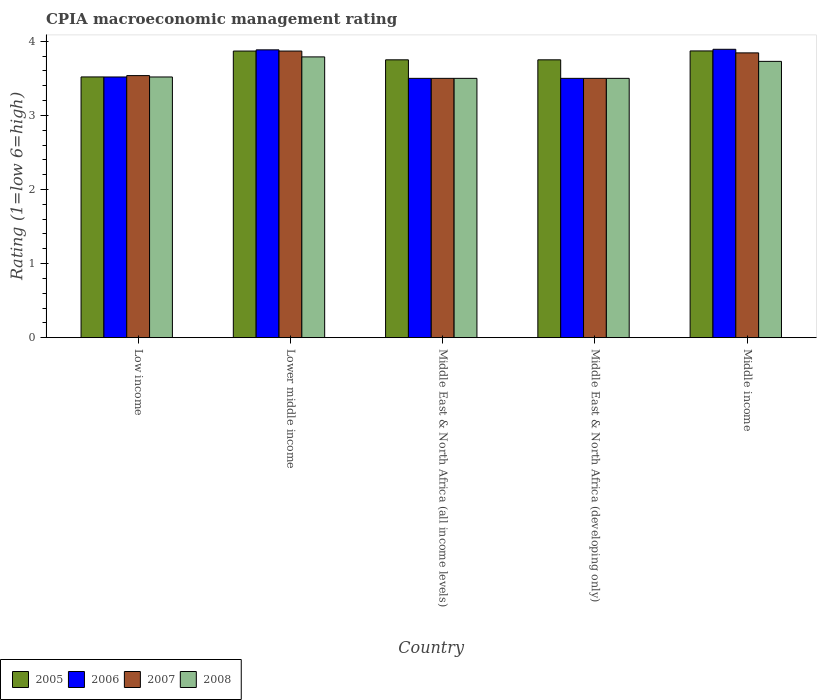How many different coloured bars are there?
Offer a very short reply. 4. How many groups of bars are there?
Your answer should be very brief. 5. Are the number of bars per tick equal to the number of legend labels?
Offer a very short reply. Yes. How many bars are there on the 3rd tick from the right?
Make the answer very short. 4. What is the label of the 4th group of bars from the left?
Offer a very short reply. Middle East & North Africa (developing only). In how many cases, is the number of bars for a given country not equal to the number of legend labels?
Ensure brevity in your answer.  0. What is the CPIA rating in 2006 in Low income?
Provide a succinct answer. 3.52. Across all countries, what is the maximum CPIA rating in 2005?
Make the answer very short. 3.87. Across all countries, what is the minimum CPIA rating in 2006?
Ensure brevity in your answer.  3.5. In which country was the CPIA rating in 2007 maximum?
Offer a terse response. Lower middle income. In which country was the CPIA rating in 2006 minimum?
Your response must be concise. Middle East & North Africa (all income levels). What is the total CPIA rating in 2008 in the graph?
Offer a terse response. 18.04. What is the difference between the CPIA rating in 2006 in Lower middle income and that in Middle income?
Your response must be concise. -0.01. What is the difference between the CPIA rating in 2007 in Middle East & North Africa (all income levels) and the CPIA rating in 2008 in Middle East & North Africa (developing only)?
Your answer should be very brief. 0. What is the average CPIA rating in 2006 per country?
Offer a very short reply. 3.66. In how many countries, is the CPIA rating in 2005 greater than 3.2?
Ensure brevity in your answer.  5. What is the ratio of the CPIA rating in 2006 in Lower middle income to that in Middle East & North Africa (all income levels)?
Provide a succinct answer. 1.11. Is the CPIA rating in 2008 in Low income less than that in Middle East & North Africa (all income levels)?
Your answer should be compact. No. What is the difference between the highest and the second highest CPIA rating in 2005?
Ensure brevity in your answer.  0.12. What is the difference between the highest and the lowest CPIA rating in 2005?
Your answer should be very brief. 0.35. Is it the case that in every country, the sum of the CPIA rating in 2008 and CPIA rating in 2007 is greater than the CPIA rating in 2006?
Offer a very short reply. Yes. How many bars are there?
Offer a terse response. 20. How many countries are there in the graph?
Your answer should be compact. 5. What is the difference between two consecutive major ticks on the Y-axis?
Ensure brevity in your answer.  1. Does the graph contain grids?
Give a very brief answer. No. How are the legend labels stacked?
Provide a succinct answer. Horizontal. What is the title of the graph?
Provide a succinct answer. CPIA macroeconomic management rating. What is the label or title of the X-axis?
Offer a very short reply. Country. What is the label or title of the Y-axis?
Offer a terse response. Rating (1=low 6=high). What is the Rating (1=low 6=high) of 2005 in Low income?
Offer a very short reply. 3.52. What is the Rating (1=low 6=high) of 2006 in Low income?
Give a very brief answer. 3.52. What is the Rating (1=low 6=high) of 2007 in Low income?
Your answer should be compact. 3.54. What is the Rating (1=low 6=high) in 2008 in Low income?
Offer a terse response. 3.52. What is the Rating (1=low 6=high) of 2005 in Lower middle income?
Provide a short and direct response. 3.87. What is the Rating (1=low 6=high) in 2006 in Lower middle income?
Offer a very short reply. 3.88. What is the Rating (1=low 6=high) in 2007 in Lower middle income?
Give a very brief answer. 3.87. What is the Rating (1=low 6=high) in 2008 in Lower middle income?
Offer a very short reply. 3.79. What is the Rating (1=low 6=high) in 2005 in Middle East & North Africa (all income levels)?
Offer a terse response. 3.75. What is the Rating (1=low 6=high) of 2006 in Middle East & North Africa (all income levels)?
Give a very brief answer. 3.5. What is the Rating (1=low 6=high) in 2005 in Middle East & North Africa (developing only)?
Offer a very short reply. 3.75. What is the Rating (1=low 6=high) in 2006 in Middle East & North Africa (developing only)?
Ensure brevity in your answer.  3.5. What is the Rating (1=low 6=high) in 2007 in Middle East & North Africa (developing only)?
Offer a very short reply. 3.5. What is the Rating (1=low 6=high) in 2008 in Middle East & North Africa (developing only)?
Your answer should be compact. 3.5. What is the Rating (1=low 6=high) of 2005 in Middle income?
Your answer should be very brief. 3.87. What is the Rating (1=low 6=high) of 2006 in Middle income?
Offer a terse response. 3.89. What is the Rating (1=low 6=high) in 2007 in Middle income?
Make the answer very short. 3.84. What is the Rating (1=low 6=high) in 2008 in Middle income?
Keep it short and to the point. 3.73. Across all countries, what is the maximum Rating (1=low 6=high) of 2005?
Your response must be concise. 3.87. Across all countries, what is the maximum Rating (1=low 6=high) in 2006?
Your response must be concise. 3.89. Across all countries, what is the maximum Rating (1=low 6=high) of 2007?
Offer a terse response. 3.87. Across all countries, what is the maximum Rating (1=low 6=high) in 2008?
Make the answer very short. 3.79. Across all countries, what is the minimum Rating (1=low 6=high) of 2005?
Give a very brief answer. 3.52. Across all countries, what is the minimum Rating (1=low 6=high) in 2006?
Offer a very short reply. 3.5. What is the total Rating (1=low 6=high) of 2005 in the graph?
Give a very brief answer. 18.76. What is the total Rating (1=low 6=high) of 2006 in the graph?
Keep it short and to the point. 18.3. What is the total Rating (1=low 6=high) in 2007 in the graph?
Ensure brevity in your answer.  18.25. What is the total Rating (1=low 6=high) in 2008 in the graph?
Your answer should be very brief. 18.04. What is the difference between the Rating (1=low 6=high) of 2005 in Low income and that in Lower middle income?
Offer a very short reply. -0.35. What is the difference between the Rating (1=low 6=high) of 2006 in Low income and that in Lower middle income?
Offer a very short reply. -0.37. What is the difference between the Rating (1=low 6=high) in 2007 in Low income and that in Lower middle income?
Give a very brief answer. -0.33. What is the difference between the Rating (1=low 6=high) in 2008 in Low income and that in Lower middle income?
Your answer should be compact. -0.27. What is the difference between the Rating (1=low 6=high) of 2005 in Low income and that in Middle East & North Africa (all income levels)?
Give a very brief answer. -0.23. What is the difference between the Rating (1=low 6=high) of 2006 in Low income and that in Middle East & North Africa (all income levels)?
Make the answer very short. 0.02. What is the difference between the Rating (1=low 6=high) of 2007 in Low income and that in Middle East & North Africa (all income levels)?
Provide a succinct answer. 0.04. What is the difference between the Rating (1=low 6=high) of 2008 in Low income and that in Middle East & North Africa (all income levels)?
Keep it short and to the point. 0.02. What is the difference between the Rating (1=low 6=high) of 2005 in Low income and that in Middle East & North Africa (developing only)?
Give a very brief answer. -0.23. What is the difference between the Rating (1=low 6=high) in 2006 in Low income and that in Middle East & North Africa (developing only)?
Make the answer very short. 0.02. What is the difference between the Rating (1=low 6=high) in 2007 in Low income and that in Middle East & North Africa (developing only)?
Keep it short and to the point. 0.04. What is the difference between the Rating (1=low 6=high) in 2008 in Low income and that in Middle East & North Africa (developing only)?
Provide a succinct answer. 0.02. What is the difference between the Rating (1=low 6=high) of 2005 in Low income and that in Middle income?
Offer a terse response. -0.35. What is the difference between the Rating (1=low 6=high) of 2006 in Low income and that in Middle income?
Provide a succinct answer. -0.37. What is the difference between the Rating (1=low 6=high) in 2007 in Low income and that in Middle income?
Provide a short and direct response. -0.31. What is the difference between the Rating (1=low 6=high) of 2008 in Low income and that in Middle income?
Your response must be concise. -0.21. What is the difference between the Rating (1=low 6=high) in 2005 in Lower middle income and that in Middle East & North Africa (all income levels)?
Offer a terse response. 0.12. What is the difference between the Rating (1=low 6=high) of 2006 in Lower middle income and that in Middle East & North Africa (all income levels)?
Give a very brief answer. 0.38. What is the difference between the Rating (1=low 6=high) of 2007 in Lower middle income and that in Middle East & North Africa (all income levels)?
Keep it short and to the point. 0.37. What is the difference between the Rating (1=low 6=high) of 2008 in Lower middle income and that in Middle East & North Africa (all income levels)?
Your answer should be very brief. 0.29. What is the difference between the Rating (1=low 6=high) in 2005 in Lower middle income and that in Middle East & North Africa (developing only)?
Ensure brevity in your answer.  0.12. What is the difference between the Rating (1=low 6=high) of 2006 in Lower middle income and that in Middle East & North Africa (developing only)?
Your answer should be very brief. 0.38. What is the difference between the Rating (1=low 6=high) in 2007 in Lower middle income and that in Middle East & North Africa (developing only)?
Provide a short and direct response. 0.37. What is the difference between the Rating (1=low 6=high) of 2008 in Lower middle income and that in Middle East & North Africa (developing only)?
Provide a succinct answer. 0.29. What is the difference between the Rating (1=low 6=high) of 2005 in Lower middle income and that in Middle income?
Ensure brevity in your answer.  -0. What is the difference between the Rating (1=low 6=high) in 2006 in Lower middle income and that in Middle income?
Offer a very short reply. -0.01. What is the difference between the Rating (1=low 6=high) in 2007 in Lower middle income and that in Middle income?
Provide a succinct answer. 0.02. What is the difference between the Rating (1=low 6=high) of 2008 in Lower middle income and that in Middle income?
Make the answer very short. 0.06. What is the difference between the Rating (1=low 6=high) of 2005 in Middle East & North Africa (all income levels) and that in Middle East & North Africa (developing only)?
Make the answer very short. 0. What is the difference between the Rating (1=low 6=high) of 2007 in Middle East & North Africa (all income levels) and that in Middle East & North Africa (developing only)?
Provide a short and direct response. 0. What is the difference between the Rating (1=low 6=high) in 2005 in Middle East & North Africa (all income levels) and that in Middle income?
Provide a short and direct response. -0.12. What is the difference between the Rating (1=low 6=high) of 2006 in Middle East & North Africa (all income levels) and that in Middle income?
Offer a very short reply. -0.39. What is the difference between the Rating (1=low 6=high) in 2007 in Middle East & North Africa (all income levels) and that in Middle income?
Offer a very short reply. -0.34. What is the difference between the Rating (1=low 6=high) in 2008 in Middle East & North Africa (all income levels) and that in Middle income?
Offer a very short reply. -0.23. What is the difference between the Rating (1=low 6=high) of 2005 in Middle East & North Africa (developing only) and that in Middle income?
Make the answer very short. -0.12. What is the difference between the Rating (1=low 6=high) in 2006 in Middle East & North Africa (developing only) and that in Middle income?
Offer a very short reply. -0.39. What is the difference between the Rating (1=low 6=high) of 2007 in Middle East & North Africa (developing only) and that in Middle income?
Make the answer very short. -0.34. What is the difference between the Rating (1=low 6=high) in 2008 in Middle East & North Africa (developing only) and that in Middle income?
Your response must be concise. -0.23. What is the difference between the Rating (1=low 6=high) of 2005 in Low income and the Rating (1=low 6=high) of 2006 in Lower middle income?
Ensure brevity in your answer.  -0.37. What is the difference between the Rating (1=low 6=high) of 2005 in Low income and the Rating (1=low 6=high) of 2007 in Lower middle income?
Provide a succinct answer. -0.35. What is the difference between the Rating (1=low 6=high) in 2005 in Low income and the Rating (1=low 6=high) in 2008 in Lower middle income?
Provide a short and direct response. -0.27. What is the difference between the Rating (1=low 6=high) of 2006 in Low income and the Rating (1=low 6=high) of 2007 in Lower middle income?
Provide a succinct answer. -0.35. What is the difference between the Rating (1=low 6=high) of 2006 in Low income and the Rating (1=low 6=high) of 2008 in Lower middle income?
Keep it short and to the point. -0.27. What is the difference between the Rating (1=low 6=high) in 2007 in Low income and the Rating (1=low 6=high) in 2008 in Lower middle income?
Provide a succinct answer. -0.25. What is the difference between the Rating (1=low 6=high) of 2005 in Low income and the Rating (1=low 6=high) of 2006 in Middle East & North Africa (all income levels)?
Ensure brevity in your answer.  0.02. What is the difference between the Rating (1=low 6=high) in 2005 in Low income and the Rating (1=low 6=high) in 2007 in Middle East & North Africa (all income levels)?
Ensure brevity in your answer.  0.02. What is the difference between the Rating (1=low 6=high) in 2005 in Low income and the Rating (1=low 6=high) in 2008 in Middle East & North Africa (all income levels)?
Your answer should be very brief. 0.02. What is the difference between the Rating (1=low 6=high) of 2006 in Low income and the Rating (1=low 6=high) of 2007 in Middle East & North Africa (all income levels)?
Provide a succinct answer. 0.02. What is the difference between the Rating (1=low 6=high) in 2006 in Low income and the Rating (1=low 6=high) in 2008 in Middle East & North Africa (all income levels)?
Your answer should be compact. 0.02. What is the difference between the Rating (1=low 6=high) of 2007 in Low income and the Rating (1=low 6=high) of 2008 in Middle East & North Africa (all income levels)?
Your answer should be compact. 0.04. What is the difference between the Rating (1=low 6=high) of 2005 in Low income and the Rating (1=low 6=high) of 2006 in Middle East & North Africa (developing only)?
Ensure brevity in your answer.  0.02. What is the difference between the Rating (1=low 6=high) of 2005 in Low income and the Rating (1=low 6=high) of 2007 in Middle East & North Africa (developing only)?
Your answer should be very brief. 0.02. What is the difference between the Rating (1=low 6=high) in 2005 in Low income and the Rating (1=low 6=high) in 2008 in Middle East & North Africa (developing only)?
Your response must be concise. 0.02. What is the difference between the Rating (1=low 6=high) of 2006 in Low income and the Rating (1=low 6=high) of 2007 in Middle East & North Africa (developing only)?
Ensure brevity in your answer.  0.02. What is the difference between the Rating (1=low 6=high) of 2006 in Low income and the Rating (1=low 6=high) of 2008 in Middle East & North Africa (developing only)?
Your response must be concise. 0.02. What is the difference between the Rating (1=low 6=high) of 2007 in Low income and the Rating (1=low 6=high) of 2008 in Middle East & North Africa (developing only)?
Your answer should be very brief. 0.04. What is the difference between the Rating (1=low 6=high) of 2005 in Low income and the Rating (1=low 6=high) of 2006 in Middle income?
Provide a succinct answer. -0.37. What is the difference between the Rating (1=low 6=high) in 2005 in Low income and the Rating (1=low 6=high) in 2007 in Middle income?
Provide a succinct answer. -0.32. What is the difference between the Rating (1=low 6=high) of 2005 in Low income and the Rating (1=low 6=high) of 2008 in Middle income?
Your response must be concise. -0.21. What is the difference between the Rating (1=low 6=high) of 2006 in Low income and the Rating (1=low 6=high) of 2007 in Middle income?
Make the answer very short. -0.33. What is the difference between the Rating (1=low 6=high) of 2006 in Low income and the Rating (1=low 6=high) of 2008 in Middle income?
Make the answer very short. -0.21. What is the difference between the Rating (1=low 6=high) of 2007 in Low income and the Rating (1=low 6=high) of 2008 in Middle income?
Your answer should be compact. -0.19. What is the difference between the Rating (1=low 6=high) in 2005 in Lower middle income and the Rating (1=low 6=high) in 2006 in Middle East & North Africa (all income levels)?
Provide a succinct answer. 0.37. What is the difference between the Rating (1=low 6=high) of 2005 in Lower middle income and the Rating (1=low 6=high) of 2007 in Middle East & North Africa (all income levels)?
Offer a very short reply. 0.37. What is the difference between the Rating (1=low 6=high) in 2005 in Lower middle income and the Rating (1=low 6=high) in 2008 in Middle East & North Africa (all income levels)?
Make the answer very short. 0.37. What is the difference between the Rating (1=low 6=high) in 2006 in Lower middle income and the Rating (1=low 6=high) in 2007 in Middle East & North Africa (all income levels)?
Give a very brief answer. 0.38. What is the difference between the Rating (1=low 6=high) in 2006 in Lower middle income and the Rating (1=low 6=high) in 2008 in Middle East & North Africa (all income levels)?
Offer a very short reply. 0.38. What is the difference between the Rating (1=low 6=high) of 2007 in Lower middle income and the Rating (1=low 6=high) of 2008 in Middle East & North Africa (all income levels)?
Offer a very short reply. 0.37. What is the difference between the Rating (1=low 6=high) in 2005 in Lower middle income and the Rating (1=low 6=high) in 2006 in Middle East & North Africa (developing only)?
Provide a succinct answer. 0.37. What is the difference between the Rating (1=low 6=high) of 2005 in Lower middle income and the Rating (1=low 6=high) of 2007 in Middle East & North Africa (developing only)?
Offer a terse response. 0.37. What is the difference between the Rating (1=low 6=high) in 2005 in Lower middle income and the Rating (1=low 6=high) in 2008 in Middle East & North Africa (developing only)?
Keep it short and to the point. 0.37. What is the difference between the Rating (1=low 6=high) in 2006 in Lower middle income and the Rating (1=low 6=high) in 2007 in Middle East & North Africa (developing only)?
Make the answer very short. 0.38. What is the difference between the Rating (1=low 6=high) of 2006 in Lower middle income and the Rating (1=low 6=high) of 2008 in Middle East & North Africa (developing only)?
Ensure brevity in your answer.  0.38. What is the difference between the Rating (1=low 6=high) in 2007 in Lower middle income and the Rating (1=low 6=high) in 2008 in Middle East & North Africa (developing only)?
Your answer should be compact. 0.37. What is the difference between the Rating (1=low 6=high) of 2005 in Lower middle income and the Rating (1=low 6=high) of 2006 in Middle income?
Keep it short and to the point. -0.02. What is the difference between the Rating (1=low 6=high) of 2005 in Lower middle income and the Rating (1=low 6=high) of 2007 in Middle income?
Your answer should be very brief. 0.02. What is the difference between the Rating (1=low 6=high) in 2005 in Lower middle income and the Rating (1=low 6=high) in 2008 in Middle income?
Offer a terse response. 0.14. What is the difference between the Rating (1=low 6=high) of 2006 in Lower middle income and the Rating (1=low 6=high) of 2007 in Middle income?
Ensure brevity in your answer.  0.04. What is the difference between the Rating (1=low 6=high) of 2006 in Lower middle income and the Rating (1=low 6=high) of 2008 in Middle income?
Make the answer very short. 0.16. What is the difference between the Rating (1=low 6=high) of 2007 in Lower middle income and the Rating (1=low 6=high) of 2008 in Middle income?
Your answer should be very brief. 0.14. What is the difference between the Rating (1=low 6=high) of 2005 in Middle East & North Africa (all income levels) and the Rating (1=low 6=high) of 2007 in Middle East & North Africa (developing only)?
Ensure brevity in your answer.  0.25. What is the difference between the Rating (1=low 6=high) of 2005 in Middle East & North Africa (all income levels) and the Rating (1=low 6=high) of 2008 in Middle East & North Africa (developing only)?
Your answer should be very brief. 0.25. What is the difference between the Rating (1=low 6=high) of 2006 in Middle East & North Africa (all income levels) and the Rating (1=low 6=high) of 2007 in Middle East & North Africa (developing only)?
Provide a short and direct response. 0. What is the difference between the Rating (1=low 6=high) in 2007 in Middle East & North Africa (all income levels) and the Rating (1=low 6=high) in 2008 in Middle East & North Africa (developing only)?
Give a very brief answer. 0. What is the difference between the Rating (1=low 6=high) of 2005 in Middle East & North Africa (all income levels) and the Rating (1=low 6=high) of 2006 in Middle income?
Your response must be concise. -0.14. What is the difference between the Rating (1=low 6=high) of 2005 in Middle East & North Africa (all income levels) and the Rating (1=low 6=high) of 2007 in Middle income?
Your answer should be compact. -0.09. What is the difference between the Rating (1=low 6=high) of 2005 in Middle East & North Africa (all income levels) and the Rating (1=low 6=high) of 2008 in Middle income?
Ensure brevity in your answer.  0.02. What is the difference between the Rating (1=low 6=high) of 2006 in Middle East & North Africa (all income levels) and the Rating (1=low 6=high) of 2007 in Middle income?
Provide a short and direct response. -0.34. What is the difference between the Rating (1=low 6=high) of 2006 in Middle East & North Africa (all income levels) and the Rating (1=low 6=high) of 2008 in Middle income?
Provide a short and direct response. -0.23. What is the difference between the Rating (1=low 6=high) in 2007 in Middle East & North Africa (all income levels) and the Rating (1=low 6=high) in 2008 in Middle income?
Your answer should be compact. -0.23. What is the difference between the Rating (1=low 6=high) in 2005 in Middle East & North Africa (developing only) and the Rating (1=low 6=high) in 2006 in Middle income?
Offer a very short reply. -0.14. What is the difference between the Rating (1=low 6=high) of 2005 in Middle East & North Africa (developing only) and the Rating (1=low 6=high) of 2007 in Middle income?
Your answer should be very brief. -0.09. What is the difference between the Rating (1=low 6=high) of 2005 in Middle East & North Africa (developing only) and the Rating (1=low 6=high) of 2008 in Middle income?
Your answer should be compact. 0.02. What is the difference between the Rating (1=low 6=high) in 2006 in Middle East & North Africa (developing only) and the Rating (1=low 6=high) in 2007 in Middle income?
Your answer should be very brief. -0.34. What is the difference between the Rating (1=low 6=high) of 2006 in Middle East & North Africa (developing only) and the Rating (1=low 6=high) of 2008 in Middle income?
Your answer should be compact. -0.23. What is the difference between the Rating (1=low 6=high) of 2007 in Middle East & North Africa (developing only) and the Rating (1=low 6=high) of 2008 in Middle income?
Offer a terse response. -0.23. What is the average Rating (1=low 6=high) in 2005 per country?
Your answer should be very brief. 3.75. What is the average Rating (1=low 6=high) of 2006 per country?
Provide a succinct answer. 3.66. What is the average Rating (1=low 6=high) in 2007 per country?
Provide a succinct answer. 3.65. What is the average Rating (1=low 6=high) of 2008 per country?
Offer a very short reply. 3.61. What is the difference between the Rating (1=low 6=high) in 2005 and Rating (1=low 6=high) in 2006 in Low income?
Provide a succinct answer. 0. What is the difference between the Rating (1=low 6=high) of 2005 and Rating (1=low 6=high) of 2007 in Low income?
Offer a terse response. -0.02. What is the difference between the Rating (1=low 6=high) in 2005 and Rating (1=low 6=high) in 2008 in Low income?
Provide a short and direct response. 0. What is the difference between the Rating (1=low 6=high) of 2006 and Rating (1=low 6=high) of 2007 in Low income?
Offer a terse response. -0.02. What is the difference between the Rating (1=low 6=high) in 2006 and Rating (1=low 6=high) in 2008 in Low income?
Keep it short and to the point. 0. What is the difference between the Rating (1=low 6=high) of 2007 and Rating (1=low 6=high) of 2008 in Low income?
Offer a terse response. 0.02. What is the difference between the Rating (1=low 6=high) of 2005 and Rating (1=low 6=high) of 2006 in Lower middle income?
Your answer should be very brief. -0.02. What is the difference between the Rating (1=low 6=high) in 2005 and Rating (1=low 6=high) in 2008 in Lower middle income?
Make the answer very short. 0.08. What is the difference between the Rating (1=low 6=high) in 2006 and Rating (1=low 6=high) in 2007 in Lower middle income?
Your response must be concise. 0.02. What is the difference between the Rating (1=low 6=high) in 2006 and Rating (1=low 6=high) in 2008 in Lower middle income?
Your answer should be very brief. 0.1. What is the difference between the Rating (1=low 6=high) of 2007 and Rating (1=low 6=high) of 2008 in Lower middle income?
Provide a short and direct response. 0.08. What is the difference between the Rating (1=low 6=high) in 2005 and Rating (1=low 6=high) in 2006 in Middle East & North Africa (all income levels)?
Provide a short and direct response. 0.25. What is the difference between the Rating (1=low 6=high) in 2005 and Rating (1=low 6=high) in 2007 in Middle East & North Africa (all income levels)?
Ensure brevity in your answer.  0.25. What is the difference between the Rating (1=low 6=high) of 2006 and Rating (1=low 6=high) of 2008 in Middle East & North Africa (all income levels)?
Give a very brief answer. 0. What is the difference between the Rating (1=low 6=high) of 2005 and Rating (1=low 6=high) of 2007 in Middle East & North Africa (developing only)?
Your answer should be very brief. 0.25. What is the difference between the Rating (1=low 6=high) in 2006 and Rating (1=low 6=high) in 2007 in Middle East & North Africa (developing only)?
Give a very brief answer. 0. What is the difference between the Rating (1=low 6=high) of 2005 and Rating (1=low 6=high) of 2006 in Middle income?
Keep it short and to the point. -0.02. What is the difference between the Rating (1=low 6=high) in 2005 and Rating (1=low 6=high) in 2007 in Middle income?
Provide a succinct answer. 0.03. What is the difference between the Rating (1=low 6=high) of 2005 and Rating (1=low 6=high) of 2008 in Middle income?
Offer a very short reply. 0.14. What is the difference between the Rating (1=low 6=high) of 2006 and Rating (1=low 6=high) of 2007 in Middle income?
Provide a succinct answer. 0.05. What is the difference between the Rating (1=low 6=high) of 2006 and Rating (1=low 6=high) of 2008 in Middle income?
Provide a succinct answer. 0.16. What is the difference between the Rating (1=low 6=high) of 2007 and Rating (1=low 6=high) of 2008 in Middle income?
Provide a short and direct response. 0.11. What is the ratio of the Rating (1=low 6=high) of 2005 in Low income to that in Lower middle income?
Provide a short and direct response. 0.91. What is the ratio of the Rating (1=low 6=high) of 2006 in Low income to that in Lower middle income?
Make the answer very short. 0.91. What is the ratio of the Rating (1=low 6=high) of 2007 in Low income to that in Lower middle income?
Provide a short and direct response. 0.91. What is the ratio of the Rating (1=low 6=high) of 2008 in Low income to that in Lower middle income?
Your response must be concise. 0.93. What is the ratio of the Rating (1=low 6=high) of 2005 in Low income to that in Middle East & North Africa (all income levels)?
Make the answer very short. 0.94. What is the ratio of the Rating (1=low 6=high) in 2007 in Low income to that in Middle East & North Africa (all income levels)?
Your response must be concise. 1.01. What is the ratio of the Rating (1=low 6=high) of 2005 in Low income to that in Middle East & North Africa (developing only)?
Provide a short and direct response. 0.94. What is the ratio of the Rating (1=low 6=high) of 2007 in Low income to that in Middle East & North Africa (developing only)?
Provide a short and direct response. 1.01. What is the ratio of the Rating (1=low 6=high) in 2005 in Low income to that in Middle income?
Keep it short and to the point. 0.91. What is the ratio of the Rating (1=low 6=high) of 2006 in Low income to that in Middle income?
Provide a succinct answer. 0.9. What is the ratio of the Rating (1=low 6=high) in 2007 in Low income to that in Middle income?
Your response must be concise. 0.92. What is the ratio of the Rating (1=low 6=high) in 2008 in Low income to that in Middle income?
Provide a succinct answer. 0.94. What is the ratio of the Rating (1=low 6=high) in 2005 in Lower middle income to that in Middle East & North Africa (all income levels)?
Offer a terse response. 1.03. What is the ratio of the Rating (1=low 6=high) of 2006 in Lower middle income to that in Middle East & North Africa (all income levels)?
Your answer should be very brief. 1.11. What is the ratio of the Rating (1=low 6=high) in 2007 in Lower middle income to that in Middle East & North Africa (all income levels)?
Keep it short and to the point. 1.11. What is the ratio of the Rating (1=low 6=high) in 2008 in Lower middle income to that in Middle East & North Africa (all income levels)?
Your answer should be very brief. 1.08. What is the ratio of the Rating (1=low 6=high) in 2005 in Lower middle income to that in Middle East & North Africa (developing only)?
Keep it short and to the point. 1.03. What is the ratio of the Rating (1=low 6=high) in 2006 in Lower middle income to that in Middle East & North Africa (developing only)?
Keep it short and to the point. 1.11. What is the ratio of the Rating (1=low 6=high) in 2007 in Lower middle income to that in Middle East & North Africa (developing only)?
Offer a terse response. 1.11. What is the ratio of the Rating (1=low 6=high) of 2008 in Lower middle income to that in Middle East & North Africa (developing only)?
Your answer should be compact. 1.08. What is the ratio of the Rating (1=low 6=high) of 2005 in Lower middle income to that in Middle income?
Ensure brevity in your answer.  1. What is the ratio of the Rating (1=low 6=high) of 2007 in Lower middle income to that in Middle income?
Provide a short and direct response. 1.01. What is the ratio of the Rating (1=low 6=high) in 2008 in Lower middle income to that in Middle income?
Your answer should be compact. 1.02. What is the ratio of the Rating (1=low 6=high) of 2005 in Middle East & North Africa (all income levels) to that in Middle East & North Africa (developing only)?
Offer a very short reply. 1. What is the ratio of the Rating (1=low 6=high) of 2007 in Middle East & North Africa (all income levels) to that in Middle East & North Africa (developing only)?
Your answer should be very brief. 1. What is the ratio of the Rating (1=low 6=high) of 2006 in Middle East & North Africa (all income levels) to that in Middle income?
Provide a short and direct response. 0.9. What is the ratio of the Rating (1=low 6=high) of 2007 in Middle East & North Africa (all income levels) to that in Middle income?
Your response must be concise. 0.91. What is the ratio of the Rating (1=low 6=high) in 2008 in Middle East & North Africa (all income levels) to that in Middle income?
Give a very brief answer. 0.94. What is the ratio of the Rating (1=low 6=high) of 2005 in Middle East & North Africa (developing only) to that in Middle income?
Your response must be concise. 0.97. What is the ratio of the Rating (1=low 6=high) of 2006 in Middle East & North Africa (developing only) to that in Middle income?
Offer a terse response. 0.9. What is the ratio of the Rating (1=low 6=high) in 2007 in Middle East & North Africa (developing only) to that in Middle income?
Provide a succinct answer. 0.91. What is the ratio of the Rating (1=low 6=high) of 2008 in Middle East & North Africa (developing only) to that in Middle income?
Make the answer very short. 0.94. What is the difference between the highest and the second highest Rating (1=low 6=high) of 2005?
Your answer should be compact. 0. What is the difference between the highest and the second highest Rating (1=low 6=high) in 2006?
Provide a short and direct response. 0.01. What is the difference between the highest and the second highest Rating (1=low 6=high) of 2007?
Offer a very short reply. 0.02. What is the difference between the highest and the second highest Rating (1=low 6=high) in 2008?
Offer a very short reply. 0.06. What is the difference between the highest and the lowest Rating (1=low 6=high) of 2005?
Your answer should be very brief. 0.35. What is the difference between the highest and the lowest Rating (1=low 6=high) of 2006?
Your answer should be very brief. 0.39. What is the difference between the highest and the lowest Rating (1=low 6=high) of 2007?
Keep it short and to the point. 0.37. What is the difference between the highest and the lowest Rating (1=low 6=high) of 2008?
Offer a very short reply. 0.29. 